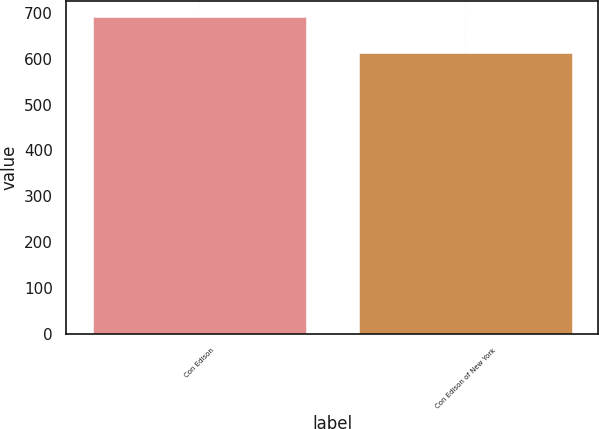<chart> <loc_0><loc_0><loc_500><loc_500><bar_chart><fcel>Con Edison<fcel>Con Edison of New York<nl><fcel>692<fcel>612<nl></chart> 